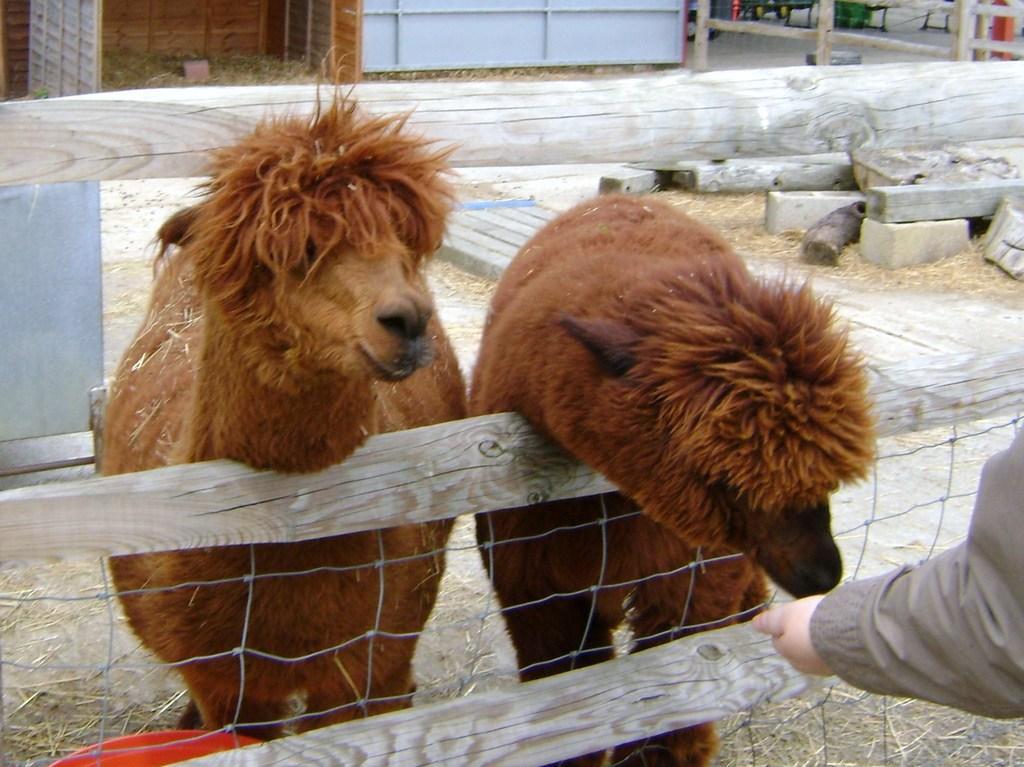In one or two sentences, can you explain what this image depicts? In this image there is a person feeding the sheep. Beside the sheep there is another sheep. In front of them there is a wooden fence. On the right side of the image there are rocks, wooden logs and a few other objects. 